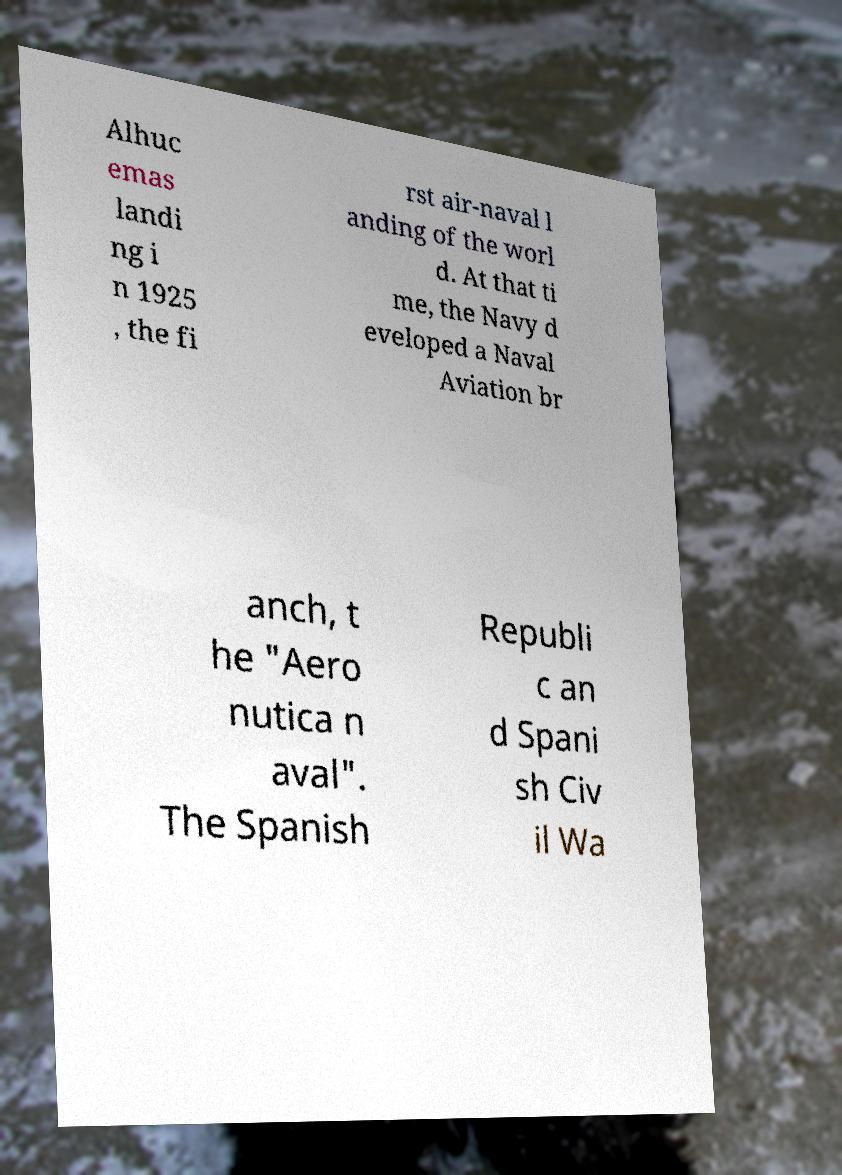Please read and relay the text visible in this image. What does it say? Alhuc emas landi ng i n 1925 , the fi rst air-naval l anding of the worl d. At that ti me, the Navy d eveloped a Naval Aviation br anch, t he "Aero nutica n aval". The Spanish Republi c an d Spani sh Civ il Wa 